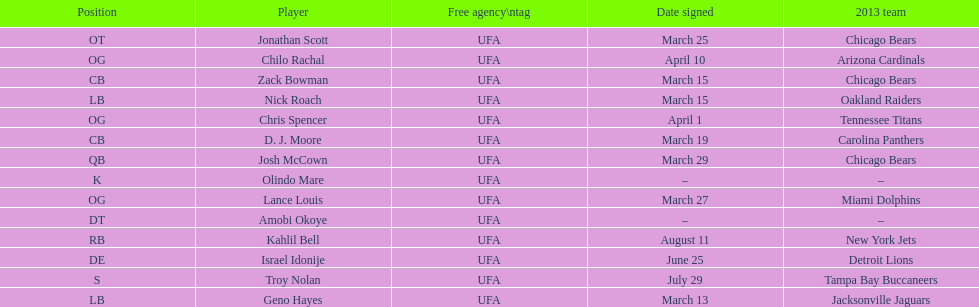Parse the table in full. {'header': ['Position', 'Player', 'Free agency\\ntag', 'Date signed', '2013 team'], 'rows': [['OT', 'Jonathan Scott', 'UFA', 'March 25', 'Chicago Bears'], ['OG', 'Chilo Rachal', 'UFA', 'April 10', 'Arizona Cardinals'], ['CB', 'Zack Bowman', 'UFA', 'March 15', 'Chicago Bears'], ['LB', 'Nick Roach', 'UFA', 'March 15', 'Oakland Raiders'], ['OG', 'Chris Spencer', 'UFA', 'April 1', 'Tennessee Titans'], ['CB', 'D. J. Moore', 'UFA', 'March 19', 'Carolina Panthers'], ['QB', 'Josh McCown', 'UFA', 'March 29', 'Chicago Bears'], ['K', 'Olindo Mare', 'UFA', '–', '–'], ['OG', 'Lance Louis', 'UFA', 'March 27', 'Miami Dolphins'], ['DT', 'Amobi Okoye', 'UFA', '–', '–'], ['RB', 'Kahlil Bell', 'UFA', 'August 11', 'New York Jets'], ['DE', 'Israel Idonije', 'UFA', 'June 25', 'Detroit Lions'], ['S', 'Troy Nolan', 'UFA', 'July 29', 'Tampa Bay Buccaneers'], ['LB', 'Geno Hayes', 'UFA', 'March 13', 'Jacksonville Jaguars']]} Geno hayes and nick roach both played which position? LB. 